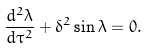<formula> <loc_0><loc_0><loc_500><loc_500>\frac { d ^ { 2 } \lambda } { d \tau ^ { 2 } } + \delta ^ { 2 } \sin \lambda = 0 .</formula> 